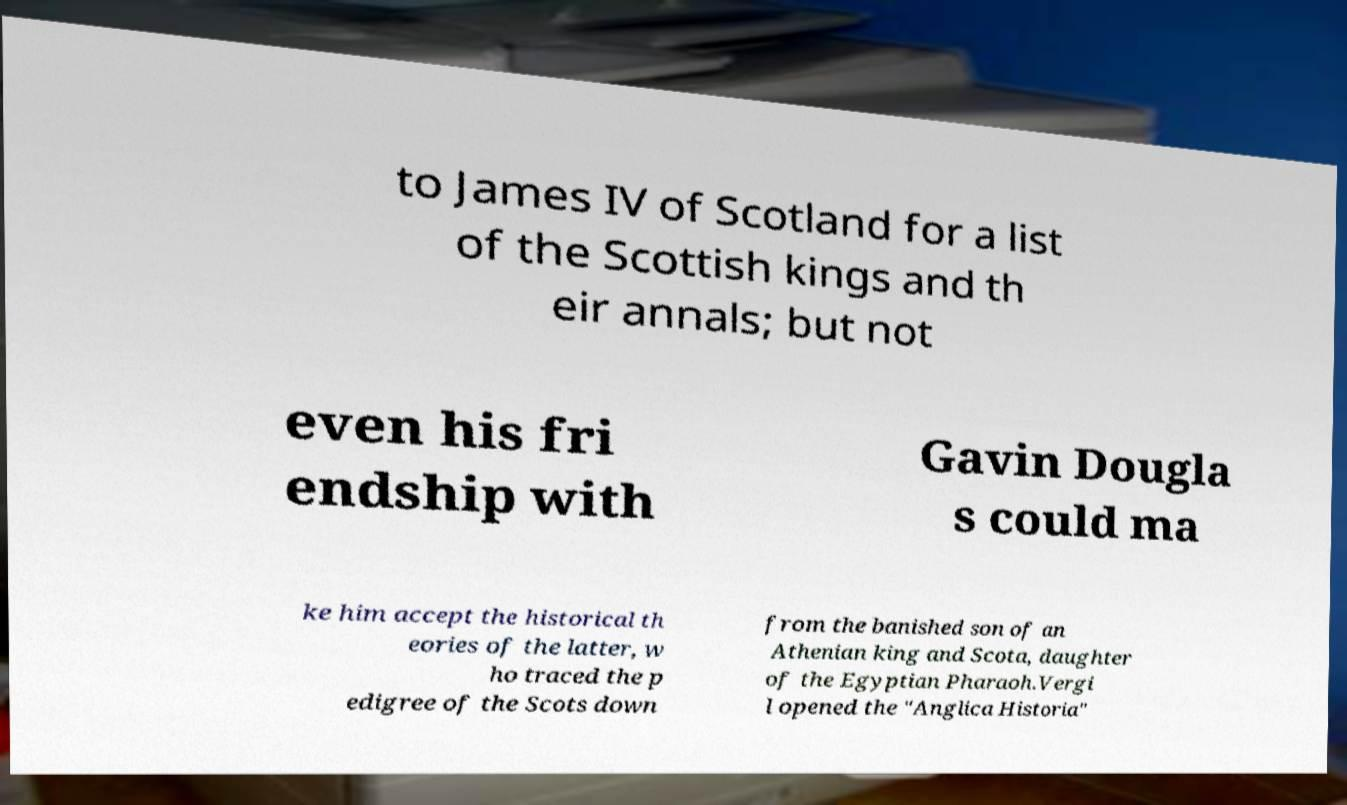Could you extract and type out the text from this image? to James IV of Scotland for a list of the Scottish kings and th eir annals; but not even his fri endship with Gavin Dougla s could ma ke him accept the historical th eories of the latter, w ho traced the p edigree of the Scots down from the banished son of an Athenian king and Scota, daughter of the Egyptian Pharaoh.Vergi l opened the "Anglica Historia" 